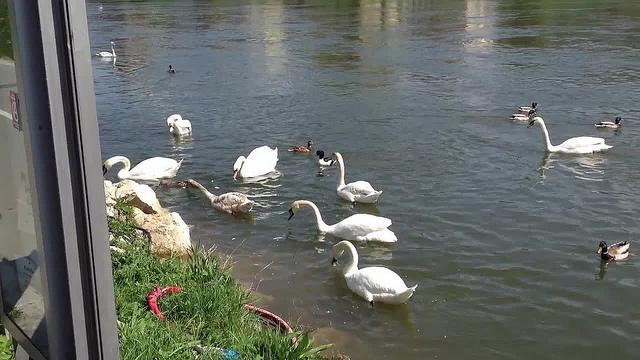How many birds are in the picture?
Answer briefly. 15. What are they doing?
Quick response, please. Swimming. What are the ducks standing behind?
Short answer required. Window. What type of bird?
Quick response, please. Swan. What kind of birds are in the water?
Short answer required. Swans. Is this water safe to drink?
Be succinct. No. How many swans are in this photo?
Be succinct. 9. 